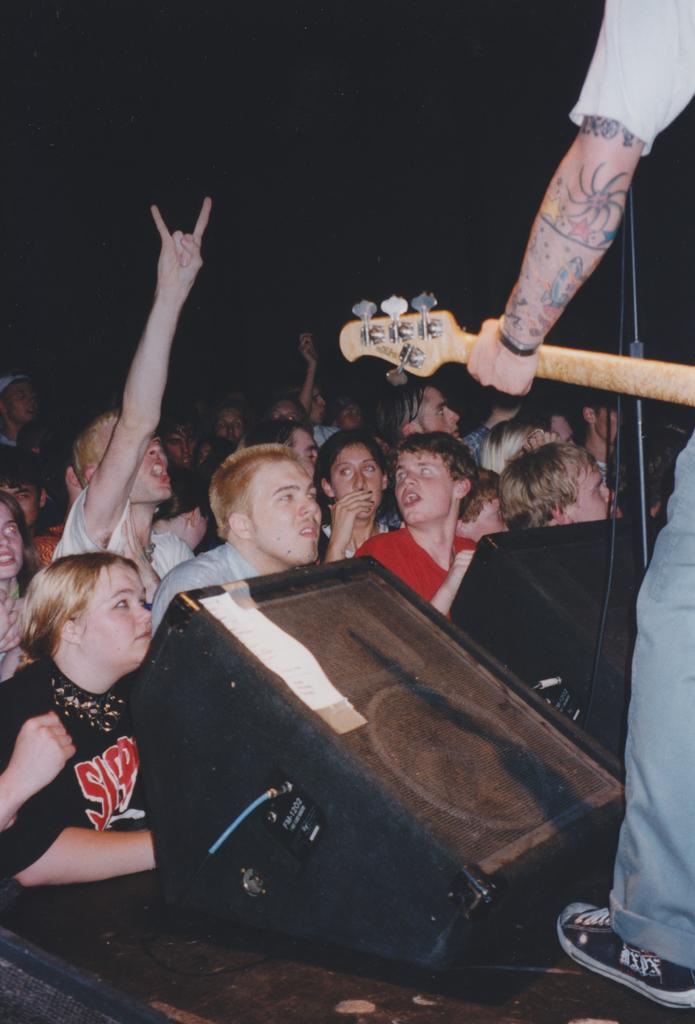How would you summarize this image in a sentence or two? In this image we can see a group of persons are standing, here a man is holding a guitar in the hands, here is the microphone, here is the stand, here is the wire. 